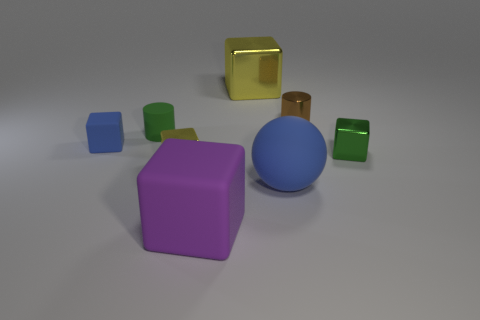Subtract all tiny blue blocks. How many blocks are left? 4 Subtract all green blocks. How many blocks are left? 4 Subtract all red blocks. Subtract all cyan cylinders. How many blocks are left? 5 Add 1 purple rubber cubes. How many objects exist? 9 Subtract all cylinders. How many objects are left? 6 Subtract 1 green cylinders. How many objects are left? 7 Subtract all small brown objects. Subtract all tiny brown metal cylinders. How many objects are left? 6 Add 1 tiny green metal cubes. How many tiny green metal cubes are left? 2 Add 8 green metallic blocks. How many green metallic blocks exist? 9 